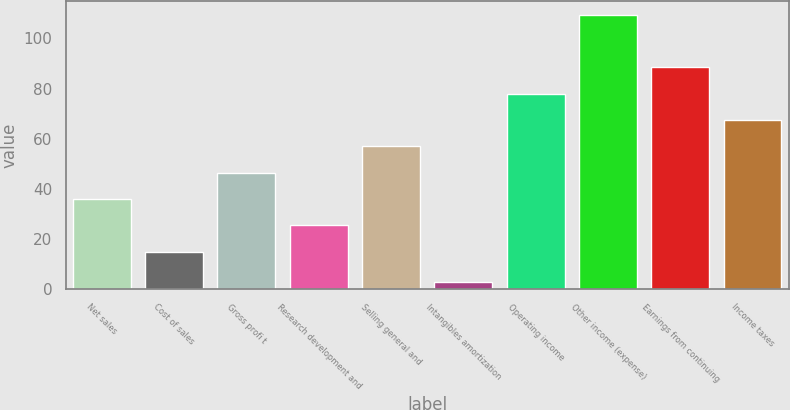Convert chart to OTSL. <chart><loc_0><loc_0><loc_500><loc_500><bar_chart><fcel>Net sales<fcel>Cost of sales<fcel>Gross profi t<fcel>Research development and<fcel>Selling general and<fcel>Intangibles amortization<fcel>Operating income<fcel>Other income (expense)<fcel>Earnings from continuing<fcel>Income taxes<nl><fcel>36<fcel>15<fcel>46.5<fcel>25.5<fcel>57<fcel>3<fcel>78<fcel>109.5<fcel>88.5<fcel>67.5<nl></chart> 